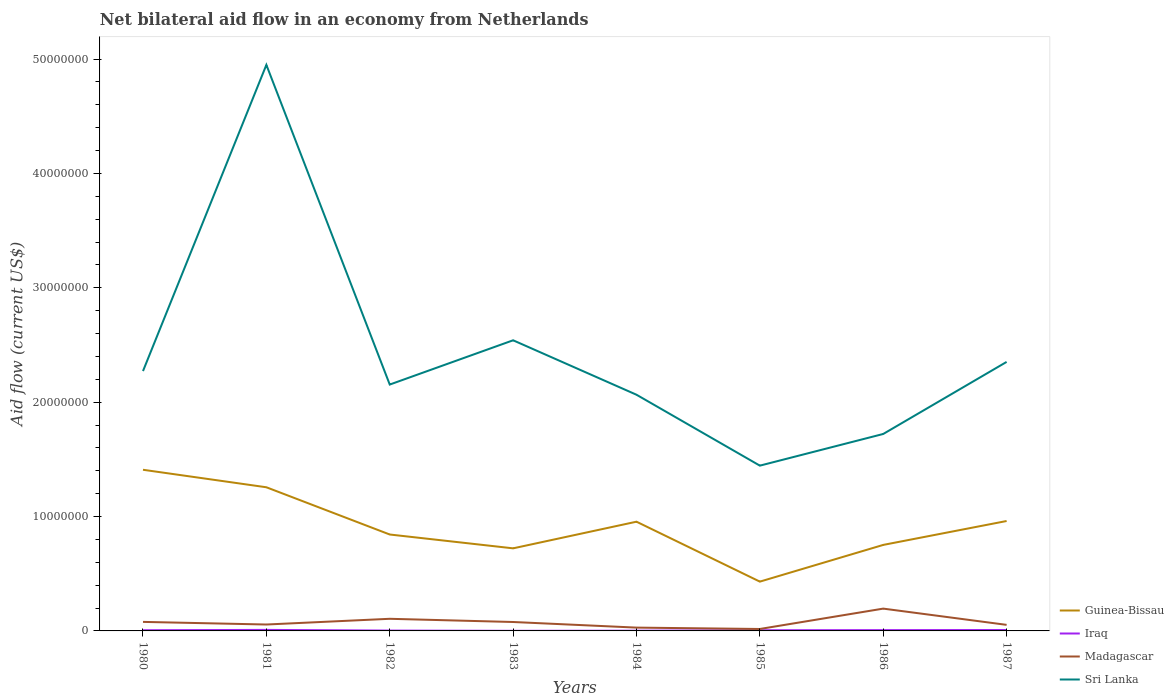What is the total net bilateral aid flow in Guinea-Bissau in the graph?
Offer a terse response. 5.04e+06. What is the difference between the highest and the second highest net bilateral aid flow in Guinea-Bissau?
Provide a short and direct response. 9.78e+06. How many years are there in the graph?
Your response must be concise. 8. Does the graph contain grids?
Provide a short and direct response. No. Where does the legend appear in the graph?
Keep it short and to the point. Bottom right. How are the legend labels stacked?
Provide a short and direct response. Vertical. What is the title of the graph?
Your answer should be compact. Net bilateral aid flow in an economy from Netherlands. What is the label or title of the X-axis?
Offer a terse response. Years. What is the Aid flow (current US$) of Guinea-Bissau in 1980?
Your response must be concise. 1.41e+07. What is the Aid flow (current US$) in Iraq in 1980?
Give a very brief answer. 6.00e+04. What is the Aid flow (current US$) of Madagascar in 1980?
Offer a terse response. 7.90e+05. What is the Aid flow (current US$) of Sri Lanka in 1980?
Ensure brevity in your answer.  2.27e+07. What is the Aid flow (current US$) of Guinea-Bissau in 1981?
Your answer should be compact. 1.26e+07. What is the Aid flow (current US$) in Madagascar in 1981?
Your answer should be very brief. 5.60e+05. What is the Aid flow (current US$) in Sri Lanka in 1981?
Give a very brief answer. 4.95e+07. What is the Aid flow (current US$) in Guinea-Bissau in 1982?
Offer a very short reply. 8.43e+06. What is the Aid flow (current US$) in Iraq in 1982?
Offer a very short reply. 3.00e+04. What is the Aid flow (current US$) of Madagascar in 1982?
Make the answer very short. 1.06e+06. What is the Aid flow (current US$) in Sri Lanka in 1982?
Provide a short and direct response. 2.15e+07. What is the Aid flow (current US$) in Guinea-Bissau in 1983?
Provide a succinct answer. 7.22e+06. What is the Aid flow (current US$) of Iraq in 1983?
Your answer should be very brief. 10000. What is the Aid flow (current US$) in Madagascar in 1983?
Provide a succinct answer. 7.80e+05. What is the Aid flow (current US$) of Sri Lanka in 1983?
Provide a short and direct response. 2.54e+07. What is the Aid flow (current US$) in Guinea-Bissau in 1984?
Offer a very short reply. 9.55e+06. What is the Aid flow (current US$) in Iraq in 1984?
Provide a succinct answer. 2.00e+04. What is the Aid flow (current US$) of Sri Lanka in 1984?
Provide a succinct answer. 2.06e+07. What is the Aid flow (current US$) of Guinea-Bissau in 1985?
Provide a short and direct response. 4.31e+06. What is the Aid flow (current US$) of Iraq in 1985?
Your response must be concise. 6.00e+04. What is the Aid flow (current US$) in Madagascar in 1985?
Give a very brief answer. 1.70e+05. What is the Aid flow (current US$) of Sri Lanka in 1985?
Make the answer very short. 1.44e+07. What is the Aid flow (current US$) of Guinea-Bissau in 1986?
Keep it short and to the point. 7.52e+06. What is the Aid flow (current US$) in Iraq in 1986?
Provide a short and direct response. 7.00e+04. What is the Aid flow (current US$) in Madagascar in 1986?
Keep it short and to the point. 1.95e+06. What is the Aid flow (current US$) of Sri Lanka in 1986?
Your answer should be very brief. 1.72e+07. What is the Aid flow (current US$) in Guinea-Bissau in 1987?
Ensure brevity in your answer.  9.61e+06. What is the Aid flow (current US$) of Iraq in 1987?
Your answer should be very brief. 8.00e+04. What is the Aid flow (current US$) of Madagascar in 1987?
Your answer should be very brief. 5.30e+05. What is the Aid flow (current US$) in Sri Lanka in 1987?
Your answer should be compact. 2.35e+07. Across all years, what is the maximum Aid flow (current US$) in Guinea-Bissau?
Keep it short and to the point. 1.41e+07. Across all years, what is the maximum Aid flow (current US$) in Madagascar?
Your answer should be compact. 1.95e+06. Across all years, what is the maximum Aid flow (current US$) in Sri Lanka?
Provide a succinct answer. 4.95e+07. Across all years, what is the minimum Aid flow (current US$) in Guinea-Bissau?
Your answer should be compact. 4.31e+06. Across all years, what is the minimum Aid flow (current US$) in Sri Lanka?
Provide a succinct answer. 1.44e+07. What is the total Aid flow (current US$) of Guinea-Bissau in the graph?
Your response must be concise. 7.33e+07. What is the total Aid flow (current US$) in Iraq in the graph?
Provide a succinct answer. 4.20e+05. What is the total Aid flow (current US$) in Madagascar in the graph?
Your response must be concise. 6.13e+06. What is the total Aid flow (current US$) of Sri Lanka in the graph?
Make the answer very short. 1.95e+08. What is the difference between the Aid flow (current US$) of Guinea-Bissau in 1980 and that in 1981?
Offer a terse response. 1.53e+06. What is the difference between the Aid flow (current US$) of Iraq in 1980 and that in 1981?
Give a very brief answer. -3.00e+04. What is the difference between the Aid flow (current US$) in Sri Lanka in 1980 and that in 1981?
Make the answer very short. -2.68e+07. What is the difference between the Aid flow (current US$) of Guinea-Bissau in 1980 and that in 1982?
Ensure brevity in your answer.  5.66e+06. What is the difference between the Aid flow (current US$) in Madagascar in 1980 and that in 1982?
Your response must be concise. -2.70e+05. What is the difference between the Aid flow (current US$) of Sri Lanka in 1980 and that in 1982?
Give a very brief answer. 1.18e+06. What is the difference between the Aid flow (current US$) in Guinea-Bissau in 1980 and that in 1983?
Offer a very short reply. 6.87e+06. What is the difference between the Aid flow (current US$) in Iraq in 1980 and that in 1983?
Ensure brevity in your answer.  5.00e+04. What is the difference between the Aid flow (current US$) of Madagascar in 1980 and that in 1983?
Provide a succinct answer. 10000. What is the difference between the Aid flow (current US$) in Sri Lanka in 1980 and that in 1983?
Keep it short and to the point. -2.69e+06. What is the difference between the Aid flow (current US$) in Guinea-Bissau in 1980 and that in 1984?
Ensure brevity in your answer.  4.54e+06. What is the difference between the Aid flow (current US$) in Iraq in 1980 and that in 1984?
Offer a very short reply. 4.00e+04. What is the difference between the Aid flow (current US$) in Madagascar in 1980 and that in 1984?
Ensure brevity in your answer.  5.00e+05. What is the difference between the Aid flow (current US$) in Sri Lanka in 1980 and that in 1984?
Give a very brief answer. 2.07e+06. What is the difference between the Aid flow (current US$) of Guinea-Bissau in 1980 and that in 1985?
Give a very brief answer. 9.78e+06. What is the difference between the Aid flow (current US$) in Iraq in 1980 and that in 1985?
Your answer should be compact. 0. What is the difference between the Aid flow (current US$) of Madagascar in 1980 and that in 1985?
Ensure brevity in your answer.  6.20e+05. What is the difference between the Aid flow (current US$) of Sri Lanka in 1980 and that in 1985?
Ensure brevity in your answer.  8.27e+06. What is the difference between the Aid flow (current US$) in Guinea-Bissau in 1980 and that in 1986?
Ensure brevity in your answer.  6.57e+06. What is the difference between the Aid flow (current US$) in Iraq in 1980 and that in 1986?
Your answer should be compact. -10000. What is the difference between the Aid flow (current US$) of Madagascar in 1980 and that in 1986?
Your answer should be compact. -1.16e+06. What is the difference between the Aid flow (current US$) in Sri Lanka in 1980 and that in 1986?
Your answer should be compact. 5.50e+06. What is the difference between the Aid flow (current US$) of Guinea-Bissau in 1980 and that in 1987?
Give a very brief answer. 4.48e+06. What is the difference between the Aid flow (current US$) in Iraq in 1980 and that in 1987?
Your answer should be very brief. -2.00e+04. What is the difference between the Aid flow (current US$) in Madagascar in 1980 and that in 1987?
Give a very brief answer. 2.60e+05. What is the difference between the Aid flow (current US$) in Sri Lanka in 1980 and that in 1987?
Make the answer very short. -8.00e+05. What is the difference between the Aid flow (current US$) of Guinea-Bissau in 1981 and that in 1982?
Give a very brief answer. 4.13e+06. What is the difference between the Aid flow (current US$) in Madagascar in 1981 and that in 1982?
Keep it short and to the point. -5.00e+05. What is the difference between the Aid flow (current US$) in Sri Lanka in 1981 and that in 1982?
Your answer should be compact. 2.80e+07. What is the difference between the Aid flow (current US$) in Guinea-Bissau in 1981 and that in 1983?
Offer a very short reply. 5.34e+06. What is the difference between the Aid flow (current US$) in Iraq in 1981 and that in 1983?
Provide a succinct answer. 8.00e+04. What is the difference between the Aid flow (current US$) in Sri Lanka in 1981 and that in 1983?
Your answer should be very brief. 2.41e+07. What is the difference between the Aid flow (current US$) of Guinea-Bissau in 1981 and that in 1984?
Your response must be concise. 3.01e+06. What is the difference between the Aid flow (current US$) in Iraq in 1981 and that in 1984?
Your answer should be very brief. 7.00e+04. What is the difference between the Aid flow (current US$) of Sri Lanka in 1981 and that in 1984?
Your answer should be very brief. 2.88e+07. What is the difference between the Aid flow (current US$) in Guinea-Bissau in 1981 and that in 1985?
Your answer should be very brief. 8.25e+06. What is the difference between the Aid flow (current US$) in Iraq in 1981 and that in 1985?
Your answer should be compact. 3.00e+04. What is the difference between the Aid flow (current US$) in Madagascar in 1981 and that in 1985?
Give a very brief answer. 3.90e+05. What is the difference between the Aid flow (current US$) in Sri Lanka in 1981 and that in 1985?
Your answer should be very brief. 3.50e+07. What is the difference between the Aid flow (current US$) of Guinea-Bissau in 1981 and that in 1986?
Provide a succinct answer. 5.04e+06. What is the difference between the Aid flow (current US$) in Iraq in 1981 and that in 1986?
Your answer should be compact. 2.00e+04. What is the difference between the Aid flow (current US$) in Madagascar in 1981 and that in 1986?
Ensure brevity in your answer.  -1.39e+06. What is the difference between the Aid flow (current US$) in Sri Lanka in 1981 and that in 1986?
Make the answer very short. 3.23e+07. What is the difference between the Aid flow (current US$) in Guinea-Bissau in 1981 and that in 1987?
Offer a very short reply. 2.95e+06. What is the difference between the Aid flow (current US$) in Iraq in 1981 and that in 1987?
Give a very brief answer. 10000. What is the difference between the Aid flow (current US$) in Madagascar in 1981 and that in 1987?
Offer a very short reply. 3.00e+04. What is the difference between the Aid flow (current US$) in Sri Lanka in 1981 and that in 1987?
Your answer should be compact. 2.60e+07. What is the difference between the Aid flow (current US$) in Guinea-Bissau in 1982 and that in 1983?
Your answer should be compact. 1.21e+06. What is the difference between the Aid flow (current US$) in Madagascar in 1982 and that in 1983?
Keep it short and to the point. 2.80e+05. What is the difference between the Aid flow (current US$) of Sri Lanka in 1982 and that in 1983?
Offer a terse response. -3.87e+06. What is the difference between the Aid flow (current US$) in Guinea-Bissau in 1982 and that in 1984?
Provide a short and direct response. -1.12e+06. What is the difference between the Aid flow (current US$) in Iraq in 1982 and that in 1984?
Make the answer very short. 10000. What is the difference between the Aid flow (current US$) of Madagascar in 1982 and that in 1984?
Give a very brief answer. 7.70e+05. What is the difference between the Aid flow (current US$) of Sri Lanka in 1982 and that in 1984?
Your answer should be very brief. 8.90e+05. What is the difference between the Aid flow (current US$) of Guinea-Bissau in 1982 and that in 1985?
Offer a terse response. 4.12e+06. What is the difference between the Aid flow (current US$) in Madagascar in 1982 and that in 1985?
Provide a short and direct response. 8.90e+05. What is the difference between the Aid flow (current US$) of Sri Lanka in 1982 and that in 1985?
Offer a very short reply. 7.09e+06. What is the difference between the Aid flow (current US$) of Guinea-Bissau in 1982 and that in 1986?
Make the answer very short. 9.10e+05. What is the difference between the Aid flow (current US$) of Madagascar in 1982 and that in 1986?
Make the answer very short. -8.90e+05. What is the difference between the Aid flow (current US$) of Sri Lanka in 1982 and that in 1986?
Keep it short and to the point. 4.32e+06. What is the difference between the Aid flow (current US$) in Guinea-Bissau in 1982 and that in 1987?
Offer a terse response. -1.18e+06. What is the difference between the Aid flow (current US$) of Madagascar in 1982 and that in 1987?
Give a very brief answer. 5.30e+05. What is the difference between the Aid flow (current US$) of Sri Lanka in 1982 and that in 1987?
Your answer should be very brief. -1.98e+06. What is the difference between the Aid flow (current US$) of Guinea-Bissau in 1983 and that in 1984?
Make the answer very short. -2.33e+06. What is the difference between the Aid flow (current US$) in Iraq in 1983 and that in 1984?
Make the answer very short. -10000. What is the difference between the Aid flow (current US$) of Sri Lanka in 1983 and that in 1984?
Your answer should be very brief. 4.76e+06. What is the difference between the Aid flow (current US$) of Guinea-Bissau in 1983 and that in 1985?
Your answer should be compact. 2.91e+06. What is the difference between the Aid flow (current US$) in Madagascar in 1983 and that in 1985?
Your response must be concise. 6.10e+05. What is the difference between the Aid flow (current US$) of Sri Lanka in 1983 and that in 1985?
Your answer should be compact. 1.10e+07. What is the difference between the Aid flow (current US$) of Madagascar in 1983 and that in 1986?
Your response must be concise. -1.17e+06. What is the difference between the Aid flow (current US$) of Sri Lanka in 1983 and that in 1986?
Make the answer very short. 8.19e+06. What is the difference between the Aid flow (current US$) in Guinea-Bissau in 1983 and that in 1987?
Give a very brief answer. -2.39e+06. What is the difference between the Aid flow (current US$) in Madagascar in 1983 and that in 1987?
Give a very brief answer. 2.50e+05. What is the difference between the Aid flow (current US$) of Sri Lanka in 1983 and that in 1987?
Your answer should be very brief. 1.89e+06. What is the difference between the Aid flow (current US$) of Guinea-Bissau in 1984 and that in 1985?
Provide a succinct answer. 5.24e+06. What is the difference between the Aid flow (current US$) of Iraq in 1984 and that in 1985?
Your answer should be very brief. -4.00e+04. What is the difference between the Aid flow (current US$) of Sri Lanka in 1984 and that in 1985?
Provide a short and direct response. 6.20e+06. What is the difference between the Aid flow (current US$) of Guinea-Bissau in 1984 and that in 1986?
Your answer should be very brief. 2.03e+06. What is the difference between the Aid flow (current US$) in Madagascar in 1984 and that in 1986?
Offer a terse response. -1.66e+06. What is the difference between the Aid flow (current US$) of Sri Lanka in 1984 and that in 1986?
Provide a succinct answer. 3.43e+06. What is the difference between the Aid flow (current US$) of Iraq in 1984 and that in 1987?
Offer a terse response. -6.00e+04. What is the difference between the Aid flow (current US$) of Madagascar in 1984 and that in 1987?
Provide a succinct answer. -2.40e+05. What is the difference between the Aid flow (current US$) in Sri Lanka in 1984 and that in 1987?
Your answer should be compact. -2.87e+06. What is the difference between the Aid flow (current US$) in Guinea-Bissau in 1985 and that in 1986?
Provide a short and direct response. -3.21e+06. What is the difference between the Aid flow (current US$) in Madagascar in 1985 and that in 1986?
Offer a terse response. -1.78e+06. What is the difference between the Aid flow (current US$) in Sri Lanka in 1985 and that in 1986?
Make the answer very short. -2.77e+06. What is the difference between the Aid flow (current US$) of Guinea-Bissau in 1985 and that in 1987?
Give a very brief answer. -5.30e+06. What is the difference between the Aid flow (current US$) in Madagascar in 1985 and that in 1987?
Keep it short and to the point. -3.60e+05. What is the difference between the Aid flow (current US$) of Sri Lanka in 1985 and that in 1987?
Provide a short and direct response. -9.07e+06. What is the difference between the Aid flow (current US$) of Guinea-Bissau in 1986 and that in 1987?
Your answer should be very brief. -2.09e+06. What is the difference between the Aid flow (current US$) in Iraq in 1986 and that in 1987?
Make the answer very short. -10000. What is the difference between the Aid flow (current US$) of Madagascar in 1986 and that in 1987?
Your response must be concise. 1.42e+06. What is the difference between the Aid flow (current US$) of Sri Lanka in 1986 and that in 1987?
Your answer should be compact. -6.30e+06. What is the difference between the Aid flow (current US$) in Guinea-Bissau in 1980 and the Aid flow (current US$) in Iraq in 1981?
Keep it short and to the point. 1.40e+07. What is the difference between the Aid flow (current US$) in Guinea-Bissau in 1980 and the Aid flow (current US$) in Madagascar in 1981?
Your answer should be compact. 1.35e+07. What is the difference between the Aid flow (current US$) in Guinea-Bissau in 1980 and the Aid flow (current US$) in Sri Lanka in 1981?
Provide a succinct answer. -3.54e+07. What is the difference between the Aid flow (current US$) of Iraq in 1980 and the Aid flow (current US$) of Madagascar in 1981?
Make the answer very short. -5.00e+05. What is the difference between the Aid flow (current US$) of Iraq in 1980 and the Aid flow (current US$) of Sri Lanka in 1981?
Ensure brevity in your answer.  -4.94e+07. What is the difference between the Aid flow (current US$) of Madagascar in 1980 and the Aid flow (current US$) of Sri Lanka in 1981?
Your answer should be compact. -4.87e+07. What is the difference between the Aid flow (current US$) of Guinea-Bissau in 1980 and the Aid flow (current US$) of Iraq in 1982?
Your response must be concise. 1.41e+07. What is the difference between the Aid flow (current US$) of Guinea-Bissau in 1980 and the Aid flow (current US$) of Madagascar in 1982?
Make the answer very short. 1.30e+07. What is the difference between the Aid flow (current US$) of Guinea-Bissau in 1980 and the Aid flow (current US$) of Sri Lanka in 1982?
Offer a very short reply. -7.45e+06. What is the difference between the Aid flow (current US$) of Iraq in 1980 and the Aid flow (current US$) of Madagascar in 1982?
Ensure brevity in your answer.  -1.00e+06. What is the difference between the Aid flow (current US$) of Iraq in 1980 and the Aid flow (current US$) of Sri Lanka in 1982?
Make the answer very short. -2.15e+07. What is the difference between the Aid flow (current US$) of Madagascar in 1980 and the Aid flow (current US$) of Sri Lanka in 1982?
Your answer should be very brief. -2.08e+07. What is the difference between the Aid flow (current US$) in Guinea-Bissau in 1980 and the Aid flow (current US$) in Iraq in 1983?
Offer a very short reply. 1.41e+07. What is the difference between the Aid flow (current US$) in Guinea-Bissau in 1980 and the Aid flow (current US$) in Madagascar in 1983?
Ensure brevity in your answer.  1.33e+07. What is the difference between the Aid flow (current US$) of Guinea-Bissau in 1980 and the Aid flow (current US$) of Sri Lanka in 1983?
Make the answer very short. -1.13e+07. What is the difference between the Aid flow (current US$) of Iraq in 1980 and the Aid flow (current US$) of Madagascar in 1983?
Your answer should be compact. -7.20e+05. What is the difference between the Aid flow (current US$) in Iraq in 1980 and the Aid flow (current US$) in Sri Lanka in 1983?
Offer a very short reply. -2.54e+07. What is the difference between the Aid flow (current US$) in Madagascar in 1980 and the Aid flow (current US$) in Sri Lanka in 1983?
Provide a short and direct response. -2.46e+07. What is the difference between the Aid flow (current US$) of Guinea-Bissau in 1980 and the Aid flow (current US$) of Iraq in 1984?
Provide a succinct answer. 1.41e+07. What is the difference between the Aid flow (current US$) of Guinea-Bissau in 1980 and the Aid flow (current US$) of Madagascar in 1984?
Keep it short and to the point. 1.38e+07. What is the difference between the Aid flow (current US$) in Guinea-Bissau in 1980 and the Aid flow (current US$) in Sri Lanka in 1984?
Your response must be concise. -6.56e+06. What is the difference between the Aid flow (current US$) of Iraq in 1980 and the Aid flow (current US$) of Sri Lanka in 1984?
Offer a terse response. -2.06e+07. What is the difference between the Aid flow (current US$) in Madagascar in 1980 and the Aid flow (current US$) in Sri Lanka in 1984?
Keep it short and to the point. -1.99e+07. What is the difference between the Aid flow (current US$) of Guinea-Bissau in 1980 and the Aid flow (current US$) of Iraq in 1985?
Provide a short and direct response. 1.40e+07. What is the difference between the Aid flow (current US$) of Guinea-Bissau in 1980 and the Aid flow (current US$) of Madagascar in 1985?
Offer a terse response. 1.39e+07. What is the difference between the Aid flow (current US$) in Guinea-Bissau in 1980 and the Aid flow (current US$) in Sri Lanka in 1985?
Offer a very short reply. -3.60e+05. What is the difference between the Aid flow (current US$) of Iraq in 1980 and the Aid flow (current US$) of Madagascar in 1985?
Offer a very short reply. -1.10e+05. What is the difference between the Aid flow (current US$) in Iraq in 1980 and the Aid flow (current US$) in Sri Lanka in 1985?
Offer a very short reply. -1.44e+07. What is the difference between the Aid flow (current US$) of Madagascar in 1980 and the Aid flow (current US$) of Sri Lanka in 1985?
Keep it short and to the point. -1.37e+07. What is the difference between the Aid flow (current US$) in Guinea-Bissau in 1980 and the Aid flow (current US$) in Iraq in 1986?
Provide a short and direct response. 1.40e+07. What is the difference between the Aid flow (current US$) in Guinea-Bissau in 1980 and the Aid flow (current US$) in Madagascar in 1986?
Your answer should be very brief. 1.21e+07. What is the difference between the Aid flow (current US$) of Guinea-Bissau in 1980 and the Aid flow (current US$) of Sri Lanka in 1986?
Provide a succinct answer. -3.13e+06. What is the difference between the Aid flow (current US$) of Iraq in 1980 and the Aid flow (current US$) of Madagascar in 1986?
Offer a very short reply. -1.89e+06. What is the difference between the Aid flow (current US$) in Iraq in 1980 and the Aid flow (current US$) in Sri Lanka in 1986?
Keep it short and to the point. -1.72e+07. What is the difference between the Aid flow (current US$) in Madagascar in 1980 and the Aid flow (current US$) in Sri Lanka in 1986?
Your response must be concise. -1.64e+07. What is the difference between the Aid flow (current US$) of Guinea-Bissau in 1980 and the Aid flow (current US$) of Iraq in 1987?
Your answer should be compact. 1.40e+07. What is the difference between the Aid flow (current US$) of Guinea-Bissau in 1980 and the Aid flow (current US$) of Madagascar in 1987?
Give a very brief answer. 1.36e+07. What is the difference between the Aid flow (current US$) in Guinea-Bissau in 1980 and the Aid flow (current US$) in Sri Lanka in 1987?
Your response must be concise. -9.43e+06. What is the difference between the Aid flow (current US$) of Iraq in 1980 and the Aid flow (current US$) of Madagascar in 1987?
Ensure brevity in your answer.  -4.70e+05. What is the difference between the Aid flow (current US$) in Iraq in 1980 and the Aid flow (current US$) in Sri Lanka in 1987?
Provide a short and direct response. -2.35e+07. What is the difference between the Aid flow (current US$) of Madagascar in 1980 and the Aid flow (current US$) of Sri Lanka in 1987?
Your answer should be very brief. -2.27e+07. What is the difference between the Aid flow (current US$) in Guinea-Bissau in 1981 and the Aid flow (current US$) in Iraq in 1982?
Keep it short and to the point. 1.25e+07. What is the difference between the Aid flow (current US$) in Guinea-Bissau in 1981 and the Aid flow (current US$) in Madagascar in 1982?
Your answer should be compact. 1.15e+07. What is the difference between the Aid flow (current US$) of Guinea-Bissau in 1981 and the Aid flow (current US$) of Sri Lanka in 1982?
Provide a succinct answer. -8.98e+06. What is the difference between the Aid flow (current US$) in Iraq in 1981 and the Aid flow (current US$) in Madagascar in 1982?
Give a very brief answer. -9.70e+05. What is the difference between the Aid flow (current US$) in Iraq in 1981 and the Aid flow (current US$) in Sri Lanka in 1982?
Give a very brief answer. -2.14e+07. What is the difference between the Aid flow (current US$) of Madagascar in 1981 and the Aid flow (current US$) of Sri Lanka in 1982?
Offer a terse response. -2.10e+07. What is the difference between the Aid flow (current US$) in Guinea-Bissau in 1981 and the Aid flow (current US$) in Iraq in 1983?
Make the answer very short. 1.26e+07. What is the difference between the Aid flow (current US$) of Guinea-Bissau in 1981 and the Aid flow (current US$) of Madagascar in 1983?
Your answer should be compact. 1.18e+07. What is the difference between the Aid flow (current US$) of Guinea-Bissau in 1981 and the Aid flow (current US$) of Sri Lanka in 1983?
Keep it short and to the point. -1.28e+07. What is the difference between the Aid flow (current US$) of Iraq in 1981 and the Aid flow (current US$) of Madagascar in 1983?
Provide a short and direct response. -6.90e+05. What is the difference between the Aid flow (current US$) of Iraq in 1981 and the Aid flow (current US$) of Sri Lanka in 1983?
Make the answer very short. -2.53e+07. What is the difference between the Aid flow (current US$) in Madagascar in 1981 and the Aid flow (current US$) in Sri Lanka in 1983?
Your response must be concise. -2.48e+07. What is the difference between the Aid flow (current US$) of Guinea-Bissau in 1981 and the Aid flow (current US$) of Iraq in 1984?
Give a very brief answer. 1.25e+07. What is the difference between the Aid flow (current US$) of Guinea-Bissau in 1981 and the Aid flow (current US$) of Madagascar in 1984?
Your response must be concise. 1.23e+07. What is the difference between the Aid flow (current US$) in Guinea-Bissau in 1981 and the Aid flow (current US$) in Sri Lanka in 1984?
Your response must be concise. -8.09e+06. What is the difference between the Aid flow (current US$) of Iraq in 1981 and the Aid flow (current US$) of Sri Lanka in 1984?
Provide a short and direct response. -2.06e+07. What is the difference between the Aid flow (current US$) in Madagascar in 1981 and the Aid flow (current US$) in Sri Lanka in 1984?
Make the answer very short. -2.01e+07. What is the difference between the Aid flow (current US$) in Guinea-Bissau in 1981 and the Aid flow (current US$) in Iraq in 1985?
Make the answer very short. 1.25e+07. What is the difference between the Aid flow (current US$) of Guinea-Bissau in 1981 and the Aid flow (current US$) of Madagascar in 1985?
Ensure brevity in your answer.  1.24e+07. What is the difference between the Aid flow (current US$) of Guinea-Bissau in 1981 and the Aid flow (current US$) of Sri Lanka in 1985?
Keep it short and to the point. -1.89e+06. What is the difference between the Aid flow (current US$) in Iraq in 1981 and the Aid flow (current US$) in Sri Lanka in 1985?
Offer a terse response. -1.44e+07. What is the difference between the Aid flow (current US$) in Madagascar in 1981 and the Aid flow (current US$) in Sri Lanka in 1985?
Your response must be concise. -1.39e+07. What is the difference between the Aid flow (current US$) in Guinea-Bissau in 1981 and the Aid flow (current US$) in Iraq in 1986?
Make the answer very short. 1.25e+07. What is the difference between the Aid flow (current US$) in Guinea-Bissau in 1981 and the Aid flow (current US$) in Madagascar in 1986?
Make the answer very short. 1.06e+07. What is the difference between the Aid flow (current US$) in Guinea-Bissau in 1981 and the Aid flow (current US$) in Sri Lanka in 1986?
Offer a very short reply. -4.66e+06. What is the difference between the Aid flow (current US$) in Iraq in 1981 and the Aid flow (current US$) in Madagascar in 1986?
Offer a terse response. -1.86e+06. What is the difference between the Aid flow (current US$) of Iraq in 1981 and the Aid flow (current US$) of Sri Lanka in 1986?
Make the answer very short. -1.71e+07. What is the difference between the Aid flow (current US$) in Madagascar in 1981 and the Aid flow (current US$) in Sri Lanka in 1986?
Ensure brevity in your answer.  -1.67e+07. What is the difference between the Aid flow (current US$) in Guinea-Bissau in 1981 and the Aid flow (current US$) in Iraq in 1987?
Give a very brief answer. 1.25e+07. What is the difference between the Aid flow (current US$) in Guinea-Bissau in 1981 and the Aid flow (current US$) in Madagascar in 1987?
Offer a terse response. 1.20e+07. What is the difference between the Aid flow (current US$) in Guinea-Bissau in 1981 and the Aid flow (current US$) in Sri Lanka in 1987?
Your response must be concise. -1.10e+07. What is the difference between the Aid flow (current US$) in Iraq in 1981 and the Aid flow (current US$) in Madagascar in 1987?
Offer a very short reply. -4.40e+05. What is the difference between the Aid flow (current US$) in Iraq in 1981 and the Aid flow (current US$) in Sri Lanka in 1987?
Your response must be concise. -2.34e+07. What is the difference between the Aid flow (current US$) of Madagascar in 1981 and the Aid flow (current US$) of Sri Lanka in 1987?
Provide a succinct answer. -2.30e+07. What is the difference between the Aid flow (current US$) in Guinea-Bissau in 1982 and the Aid flow (current US$) in Iraq in 1983?
Your answer should be compact. 8.42e+06. What is the difference between the Aid flow (current US$) of Guinea-Bissau in 1982 and the Aid flow (current US$) of Madagascar in 1983?
Make the answer very short. 7.65e+06. What is the difference between the Aid flow (current US$) of Guinea-Bissau in 1982 and the Aid flow (current US$) of Sri Lanka in 1983?
Your response must be concise. -1.70e+07. What is the difference between the Aid flow (current US$) in Iraq in 1982 and the Aid flow (current US$) in Madagascar in 1983?
Make the answer very short. -7.50e+05. What is the difference between the Aid flow (current US$) of Iraq in 1982 and the Aid flow (current US$) of Sri Lanka in 1983?
Offer a very short reply. -2.54e+07. What is the difference between the Aid flow (current US$) of Madagascar in 1982 and the Aid flow (current US$) of Sri Lanka in 1983?
Your response must be concise. -2.44e+07. What is the difference between the Aid flow (current US$) of Guinea-Bissau in 1982 and the Aid flow (current US$) of Iraq in 1984?
Make the answer very short. 8.41e+06. What is the difference between the Aid flow (current US$) in Guinea-Bissau in 1982 and the Aid flow (current US$) in Madagascar in 1984?
Make the answer very short. 8.14e+06. What is the difference between the Aid flow (current US$) in Guinea-Bissau in 1982 and the Aid flow (current US$) in Sri Lanka in 1984?
Give a very brief answer. -1.22e+07. What is the difference between the Aid flow (current US$) in Iraq in 1982 and the Aid flow (current US$) in Sri Lanka in 1984?
Your response must be concise. -2.06e+07. What is the difference between the Aid flow (current US$) of Madagascar in 1982 and the Aid flow (current US$) of Sri Lanka in 1984?
Your answer should be very brief. -1.96e+07. What is the difference between the Aid flow (current US$) of Guinea-Bissau in 1982 and the Aid flow (current US$) of Iraq in 1985?
Ensure brevity in your answer.  8.37e+06. What is the difference between the Aid flow (current US$) in Guinea-Bissau in 1982 and the Aid flow (current US$) in Madagascar in 1985?
Make the answer very short. 8.26e+06. What is the difference between the Aid flow (current US$) of Guinea-Bissau in 1982 and the Aid flow (current US$) of Sri Lanka in 1985?
Ensure brevity in your answer.  -6.02e+06. What is the difference between the Aid flow (current US$) of Iraq in 1982 and the Aid flow (current US$) of Sri Lanka in 1985?
Offer a terse response. -1.44e+07. What is the difference between the Aid flow (current US$) of Madagascar in 1982 and the Aid flow (current US$) of Sri Lanka in 1985?
Keep it short and to the point. -1.34e+07. What is the difference between the Aid flow (current US$) in Guinea-Bissau in 1982 and the Aid flow (current US$) in Iraq in 1986?
Your answer should be very brief. 8.36e+06. What is the difference between the Aid flow (current US$) of Guinea-Bissau in 1982 and the Aid flow (current US$) of Madagascar in 1986?
Your response must be concise. 6.48e+06. What is the difference between the Aid flow (current US$) in Guinea-Bissau in 1982 and the Aid flow (current US$) in Sri Lanka in 1986?
Ensure brevity in your answer.  -8.79e+06. What is the difference between the Aid flow (current US$) of Iraq in 1982 and the Aid flow (current US$) of Madagascar in 1986?
Your response must be concise. -1.92e+06. What is the difference between the Aid flow (current US$) of Iraq in 1982 and the Aid flow (current US$) of Sri Lanka in 1986?
Make the answer very short. -1.72e+07. What is the difference between the Aid flow (current US$) in Madagascar in 1982 and the Aid flow (current US$) in Sri Lanka in 1986?
Your response must be concise. -1.62e+07. What is the difference between the Aid flow (current US$) in Guinea-Bissau in 1982 and the Aid flow (current US$) in Iraq in 1987?
Offer a very short reply. 8.35e+06. What is the difference between the Aid flow (current US$) in Guinea-Bissau in 1982 and the Aid flow (current US$) in Madagascar in 1987?
Make the answer very short. 7.90e+06. What is the difference between the Aid flow (current US$) of Guinea-Bissau in 1982 and the Aid flow (current US$) of Sri Lanka in 1987?
Your answer should be compact. -1.51e+07. What is the difference between the Aid flow (current US$) in Iraq in 1982 and the Aid flow (current US$) in Madagascar in 1987?
Offer a very short reply. -5.00e+05. What is the difference between the Aid flow (current US$) in Iraq in 1982 and the Aid flow (current US$) in Sri Lanka in 1987?
Offer a very short reply. -2.35e+07. What is the difference between the Aid flow (current US$) in Madagascar in 1982 and the Aid flow (current US$) in Sri Lanka in 1987?
Ensure brevity in your answer.  -2.25e+07. What is the difference between the Aid flow (current US$) in Guinea-Bissau in 1983 and the Aid flow (current US$) in Iraq in 1984?
Your answer should be very brief. 7.20e+06. What is the difference between the Aid flow (current US$) of Guinea-Bissau in 1983 and the Aid flow (current US$) of Madagascar in 1984?
Give a very brief answer. 6.93e+06. What is the difference between the Aid flow (current US$) in Guinea-Bissau in 1983 and the Aid flow (current US$) in Sri Lanka in 1984?
Give a very brief answer. -1.34e+07. What is the difference between the Aid flow (current US$) in Iraq in 1983 and the Aid flow (current US$) in Madagascar in 1984?
Provide a short and direct response. -2.80e+05. What is the difference between the Aid flow (current US$) of Iraq in 1983 and the Aid flow (current US$) of Sri Lanka in 1984?
Your answer should be compact. -2.06e+07. What is the difference between the Aid flow (current US$) in Madagascar in 1983 and the Aid flow (current US$) in Sri Lanka in 1984?
Your answer should be very brief. -1.99e+07. What is the difference between the Aid flow (current US$) in Guinea-Bissau in 1983 and the Aid flow (current US$) in Iraq in 1985?
Your response must be concise. 7.16e+06. What is the difference between the Aid flow (current US$) of Guinea-Bissau in 1983 and the Aid flow (current US$) of Madagascar in 1985?
Your response must be concise. 7.05e+06. What is the difference between the Aid flow (current US$) in Guinea-Bissau in 1983 and the Aid flow (current US$) in Sri Lanka in 1985?
Make the answer very short. -7.23e+06. What is the difference between the Aid flow (current US$) of Iraq in 1983 and the Aid flow (current US$) of Madagascar in 1985?
Ensure brevity in your answer.  -1.60e+05. What is the difference between the Aid flow (current US$) in Iraq in 1983 and the Aid flow (current US$) in Sri Lanka in 1985?
Your answer should be very brief. -1.44e+07. What is the difference between the Aid flow (current US$) in Madagascar in 1983 and the Aid flow (current US$) in Sri Lanka in 1985?
Ensure brevity in your answer.  -1.37e+07. What is the difference between the Aid flow (current US$) in Guinea-Bissau in 1983 and the Aid flow (current US$) in Iraq in 1986?
Provide a short and direct response. 7.15e+06. What is the difference between the Aid flow (current US$) of Guinea-Bissau in 1983 and the Aid flow (current US$) of Madagascar in 1986?
Your answer should be compact. 5.27e+06. What is the difference between the Aid flow (current US$) of Guinea-Bissau in 1983 and the Aid flow (current US$) of Sri Lanka in 1986?
Your answer should be compact. -1.00e+07. What is the difference between the Aid flow (current US$) in Iraq in 1983 and the Aid flow (current US$) in Madagascar in 1986?
Give a very brief answer. -1.94e+06. What is the difference between the Aid flow (current US$) in Iraq in 1983 and the Aid flow (current US$) in Sri Lanka in 1986?
Offer a terse response. -1.72e+07. What is the difference between the Aid flow (current US$) in Madagascar in 1983 and the Aid flow (current US$) in Sri Lanka in 1986?
Offer a terse response. -1.64e+07. What is the difference between the Aid flow (current US$) in Guinea-Bissau in 1983 and the Aid flow (current US$) in Iraq in 1987?
Offer a terse response. 7.14e+06. What is the difference between the Aid flow (current US$) of Guinea-Bissau in 1983 and the Aid flow (current US$) of Madagascar in 1987?
Your answer should be very brief. 6.69e+06. What is the difference between the Aid flow (current US$) of Guinea-Bissau in 1983 and the Aid flow (current US$) of Sri Lanka in 1987?
Offer a terse response. -1.63e+07. What is the difference between the Aid flow (current US$) of Iraq in 1983 and the Aid flow (current US$) of Madagascar in 1987?
Provide a short and direct response. -5.20e+05. What is the difference between the Aid flow (current US$) in Iraq in 1983 and the Aid flow (current US$) in Sri Lanka in 1987?
Offer a very short reply. -2.35e+07. What is the difference between the Aid flow (current US$) in Madagascar in 1983 and the Aid flow (current US$) in Sri Lanka in 1987?
Keep it short and to the point. -2.27e+07. What is the difference between the Aid flow (current US$) in Guinea-Bissau in 1984 and the Aid flow (current US$) in Iraq in 1985?
Provide a succinct answer. 9.49e+06. What is the difference between the Aid flow (current US$) of Guinea-Bissau in 1984 and the Aid flow (current US$) of Madagascar in 1985?
Offer a terse response. 9.38e+06. What is the difference between the Aid flow (current US$) in Guinea-Bissau in 1984 and the Aid flow (current US$) in Sri Lanka in 1985?
Offer a very short reply. -4.90e+06. What is the difference between the Aid flow (current US$) of Iraq in 1984 and the Aid flow (current US$) of Sri Lanka in 1985?
Ensure brevity in your answer.  -1.44e+07. What is the difference between the Aid flow (current US$) of Madagascar in 1984 and the Aid flow (current US$) of Sri Lanka in 1985?
Your answer should be compact. -1.42e+07. What is the difference between the Aid flow (current US$) in Guinea-Bissau in 1984 and the Aid flow (current US$) in Iraq in 1986?
Your response must be concise. 9.48e+06. What is the difference between the Aid flow (current US$) in Guinea-Bissau in 1984 and the Aid flow (current US$) in Madagascar in 1986?
Your answer should be compact. 7.60e+06. What is the difference between the Aid flow (current US$) of Guinea-Bissau in 1984 and the Aid flow (current US$) of Sri Lanka in 1986?
Provide a succinct answer. -7.67e+06. What is the difference between the Aid flow (current US$) in Iraq in 1984 and the Aid flow (current US$) in Madagascar in 1986?
Give a very brief answer. -1.93e+06. What is the difference between the Aid flow (current US$) of Iraq in 1984 and the Aid flow (current US$) of Sri Lanka in 1986?
Make the answer very short. -1.72e+07. What is the difference between the Aid flow (current US$) of Madagascar in 1984 and the Aid flow (current US$) of Sri Lanka in 1986?
Provide a succinct answer. -1.69e+07. What is the difference between the Aid flow (current US$) of Guinea-Bissau in 1984 and the Aid flow (current US$) of Iraq in 1987?
Make the answer very short. 9.47e+06. What is the difference between the Aid flow (current US$) of Guinea-Bissau in 1984 and the Aid flow (current US$) of Madagascar in 1987?
Provide a succinct answer. 9.02e+06. What is the difference between the Aid flow (current US$) in Guinea-Bissau in 1984 and the Aid flow (current US$) in Sri Lanka in 1987?
Offer a very short reply. -1.40e+07. What is the difference between the Aid flow (current US$) in Iraq in 1984 and the Aid flow (current US$) in Madagascar in 1987?
Your response must be concise. -5.10e+05. What is the difference between the Aid flow (current US$) of Iraq in 1984 and the Aid flow (current US$) of Sri Lanka in 1987?
Offer a very short reply. -2.35e+07. What is the difference between the Aid flow (current US$) of Madagascar in 1984 and the Aid flow (current US$) of Sri Lanka in 1987?
Your response must be concise. -2.32e+07. What is the difference between the Aid flow (current US$) in Guinea-Bissau in 1985 and the Aid flow (current US$) in Iraq in 1986?
Provide a succinct answer. 4.24e+06. What is the difference between the Aid flow (current US$) of Guinea-Bissau in 1985 and the Aid flow (current US$) of Madagascar in 1986?
Your response must be concise. 2.36e+06. What is the difference between the Aid flow (current US$) in Guinea-Bissau in 1985 and the Aid flow (current US$) in Sri Lanka in 1986?
Make the answer very short. -1.29e+07. What is the difference between the Aid flow (current US$) in Iraq in 1985 and the Aid flow (current US$) in Madagascar in 1986?
Provide a succinct answer. -1.89e+06. What is the difference between the Aid flow (current US$) of Iraq in 1985 and the Aid flow (current US$) of Sri Lanka in 1986?
Provide a short and direct response. -1.72e+07. What is the difference between the Aid flow (current US$) of Madagascar in 1985 and the Aid flow (current US$) of Sri Lanka in 1986?
Provide a succinct answer. -1.70e+07. What is the difference between the Aid flow (current US$) of Guinea-Bissau in 1985 and the Aid flow (current US$) of Iraq in 1987?
Provide a succinct answer. 4.23e+06. What is the difference between the Aid flow (current US$) of Guinea-Bissau in 1985 and the Aid flow (current US$) of Madagascar in 1987?
Your response must be concise. 3.78e+06. What is the difference between the Aid flow (current US$) in Guinea-Bissau in 1985 and the Aid flow (current US$) in Sri Lanka in 1987?
Provide a succinct answer. -1.92e+07. What is the difference between the Aid flow (current US$) of Iraq in 1985 and the Aid flow (current US$) of Madagascar in 1987?
Keep it short and to the point. -4.70e+05. What is the difference between the Aid flow (current US$) of Iraq in 1985 and the Aid flow (current US$) of Sri Lanka in 1987?
Your answer should be compact. -2.35e+07. What is the difference between the Aid flow (current US$) of Madagascar in 1985 and the Aid flow (current US$) of Sri Lanka in 1987?
Make the answer very short. -2.34e+07. What is the difference between the Aid flow (current US$) in Guinea-Bissau in 1986 and the Aid flow (current US$) in Iraq in 1987?
Ensure brevity in your answer.  7.44e+06. What is the difference between the Aid flow (current US$) of Guinea-Bissau in 1986 and the Aid flow (current US$) of Madagascar in 1987?
Keep it short and to the point. 6.99e+06. What is the difference between the Aid flow (current US$) in Guinea-Bissau in 1986 and the Aid flow (current US$) in Sri Lanka in 1987?
Provide a short and direct response. -1.60e+07. What is the difference between the Aid flow (current US$) in Iraq in 1986 and the Aid flow (current US$) in Madagascar in 1987?
Keep it short and to the point. -4.60e+05. What is the difference between the Aid flow (current US$) of Iraq in 1986 and the Aid flow (current US$) of Sri Lanka in 1987?
Provide a short and direct response. -2.34e+07. What is the difference between the Aid flow (current US$) in Madagascar in 1986 and the Aid flow (current US$) in Sri Lanka in 1987?
Your answer should be compact. -2.16e+07. What is the average Aid flow (current US$) of Guinea-Bissau per year?
Give a very brief answer. 9.16e+06. What is the average Aid flow (current US$) in Iraq per year?
Ensure brevity in your answer.  5.25e+04. What is the average Aid flow (current US$) of Madagascar per year?
Offer a terse response. 7.66e+05. What is the average Aid flow (current US$) of Sri Lanka per year?
Keep it short and to the point. 2.44e+07. In the year 1980, what is the difference between the Aid flow (current US$) of Guinea-Bissau and Aid flow (current US$) of Iraq?
Give a very brief answer. 1.40e+07. In the year 1980, what is the difference between the Aid flow (current US$) of Guinea-Bissau and Aid flow (current US$) of Madagascar?
Give a very brief answer. 1.33e+07. In the year 1980, what is the difference between the Aid flow (current US$) of Guinea-Bissau and Aid flow (current US$) of Sri Lanka?
Make the answer very short. -8.63e+06. In the year 1980, what is the difference between the Aid flow (current US$) of Iraq and Aid flow (current US$) of Madagascar?
Give a very brief answer. -7.30e+05. In the year 1980, what is the difference between the Aid flow (current US$) in Iraq and Aid flow (current US$) in Sri Lanka?
Give a very brief answer. -2.27e+07. In the year 1980, what is the difference between the Aid flow (current US$) of Madagascar and Aid flow (current US$) of Sri Lanka?
Provide a succinct answer. -2.19e+07. In the year 1981, what is the difference between the Aid flow (current US$) in Guinea-Bissau and Aid flow (current US$) in Iraq?
Give a very brief answer. 1.25e+07. In the year 1981, what is the difference between the Aid flow (current US$) in Guinea-Bissau and Aid flow (current US$) in Sri Lanka?
Your response must be concise. -3.69e+07. In the year 1981, what is the difference between the Aid flow (current US$) in Iraq and Aid flow (current US$) in Madagascar?
Provide a short and direct response. -4.70e+05. In the year 1981, what is the difference between the Aid flow (current US$) in Iraq and Aid flow (current US$) in Sri Lanka?
Ensure brevity in your answer.  -4.94e+07. In the year 1981, what is the difference between the Aid flow (current US$) of Madagascar and Aid flow (current US$) of Sri Lanka?
Keep it short and to the point. -4.89e+07. In the year 1982, what is the difference between the Aid flow (current US$) in Guinea-Bissau and Aid flow (current US$) in Iraq?
Your answer should be very brief. 8.40e+06. In the year 1982, what is the difference between the Aid flow (current US$) of Guinea-Bissau and Aid flow (current US$) of Madagascar?
Your response must be concise. 7.37e+06. In the year 1982, what is the difference between the Aid flow (current US$) of Guinea-Bissau and Aid flow (current US$) of Sri Lanka?
Give a very brief answer. -1.31e+07. In the year 1982, what is the difference between the Aid flow (current US$) of Iraq and Aid flow (current US$) of Madagascar?
Give a very brief answer. -1.03e+06. In the year 1982, what is the difference between the Aid flow (current US$) of Iraq and Aid flow (current US$) of Sri Lanka?
Keep it short and to the point. -2.15e+07. In the year 1982, what is the difference between the Aid flow (current US$) of Madagascar and Aid flow (current US$) of Sri Lanka?
Give a very brief answer. -2.05e+07. In the year 1983, what is the difference between the Aid flow (current US$) of Guinea-Bissau and Aid flow (current US$) of Iraq?
Your answer should be compact. 7.21e+06. In the year 1983, what is the difference between the Aid flow (current US$) of Guinea-Bissau and Aid flow (current US$) of Madagascar?
Give a very brief answer. 6.44e+06. In the year 1983, what is the difference between the Aid flow (current US$) of Guinea-Bissau and Aid flow (current US$) of Sri Lanka?
Keep it short and to the point. -1.82e+07. In the year 1983, what is the difference between the Aid flow (current US$) in Iraq and Aid flow (current US$) in Madagascar?
Provide a short and direct response. -7.70e+05. In the year 1983, what is the difference between the Aid flow (current US$) of Iraq and Aid flow (current US$) of Sri Lanka?
Offer a terse response. -2.54e+07. In the year 1983, what is the difference between the Aid flow (current US$) in Madagascar and Aid flow (current US$) in Sri Lanka?
Offer a very short reply. -2.46e+07. In the year 1984, what is the difference between the Aid flow (current US$) in Guinea-Bissau and Aid flow (current US$) in Iraq?
Your answer should be very brief. 9.53e+06. In the year 1984, what is the difference between the Aid flow (current US$) of Guinea-Bissau and Aid flow (current US$) of Madagascar?
Your answer should be very brief. 9.26e+06. In the year 1984, what is the difference between the Aid flow (current US$) in Guinea-Bissau and Aid flow (current US$) in Sri Lanka?
Ensure brevity in your answer.  -1.11e+07. In the year 1984, what is the difference between the Aid flow (current US$) in Iraq and Aid flow (current US$) in Sri Lanka?
Provide a succinct answer. -2.06e+07. In the year 1984, what is the difference between the Aid flow (current US$) in Madagascar and Aid flow (current US$) in Sri Lanka?
Your answer should be compact. -2.04e+07. In the year 1985, what is the difference between the Aid flow (current US$) in Guinea-Bissau and Aid flow (current US$) in Iraq?
Offer a very short reply. 4.25e+06. In the year 1985, what is the difference between the Aid flow (current US$) in Guinea-Bissau and Aid flow (current US$) in Madagascar?
Make the answer very short. 4.14e+06. In the year 1985, what is the difference between the Aid flow (current US$) in Guinea-Bissau and Aid flow (current US$) in Sri Lanka?
Your response must be concise. -1.01e+07. In the year 1985, what is the difference between the Aid flow (current US$) in Iraq and Aid flow (current US$) in Sri Lanka?
Your answer should be very brief. -1.44e+07. In the year 1985, what is the difference between the Aid flow (current US$) in Madagascar and Aid flow (current US$) in Sri Lanka?
Your answer should be compact. -1.43e+07. In the year 1986, what is the difference between the Aid flow (current US$) of Guinea-Bissau and Aid flow (current US$) of Iraq?
Make the answer very short. 7.45e+06. In the year 1986, what is the difference between the Aid flow (current US$) of Guinea-Bissau and Aid flow (current US$) of Madagascar?
Your answer should be compact. 5.57e+06. In the year 1986, what is the difference between the Aid flow (current US$) in Guinea-Bissau and Aid flow (current US$) in Sri Lanka?
Give a very brief answer. -9.70e+06. In the year 1986, what is the difference between the Aid flow (current US$) in Iraq and Aid flow (current US$) in Madagascar?
Your answer should be very brief. -1.88e+06. In the year 1986, what is the difference between the Aid flow (current US$) of Iraq and Aid flow (current US$) of Sri Lanka?
Make the answer very short. -1.72e+07. In the year 1986, what is the difference between the Aid flow (current US$) in Madagascar and Aid flow (current US$) in Sri Lanka?
Provide a succinct answer. -1.53e+07. In the year 1987, what is the difference between the Aid flow (current US$) of Guinea-Bissau and Aid flow (current US$) of Iraq?
Offer a very short reply. 9.53e+06. In the year 1987, what is the difference between the Aid flow (current US$) in Guinea-Bissau and Aid flow (current US$) in Madagascar?
Provide a succinct answer. 9.08e+06. In the year 1987, what is the difference between the Aid flow (current US$) of Guinea-Bissau and Aid flow (current US$) of Sri Lanka?
Ensure brevity in your answer.  -1.39e+07. In the year 1987, what is the difference between the Aid flow (current US$) of Iraq and Aid flow (current US$) of Madagascar?
Your response must be concise. -4.50e+05. In the year 1987, what is the difference between the Aid flow (current US$) in Iraq and Aid flow (current US$) in Sri Lanka?
Provide a short and direct response. -2.34e+07. In the year 1987, what is the difference between the Aid flow (current US$) in Madagascar and Aid flow (current US$) in Sri Lanka?
Make the answer very short. -2.30e+07. What is the ratio of the Aid flow (current US$) of Guinea-Bissau in 1980 to that in 1981?
Offer a very short reply. 1.12. What is the ratio of the Aid flow (current US$) in Iraq in 1980 to that in 1981?
Give a very brief answer. 0.67. What is the ratio of the Aid flow (current US$) in Madagascar in 1980 to that in 1981?
Your response must be concise. 1.41. What is the ratio of the Aid flow (current US$) in Sri Lanka in 1980 to that in 1981?
Offer a very short reply. 0.46. What is the ratio of the Aid flow (current US$) of Guinea-Bissau in 1980 to that in 1982?
Your answer should be very brief. 1.67. What is the ratio of the Aid flow (current US$) in Madagascar in 1980 to that in 1982?
Offer a terse response. 0.75. What is the ratio of the Aid flow (current US$) of Sri Lanka in 1980 to that in 1982?
Your answer should be very brief. 1.05. What is the ratio of the Aid flow (current US$) of Guinea-Bissau in 1980 to that in 1983?
Ensure brevity in your answer.  1.95. What is the ratio of the Aid flow (current US$) of Iraq in 1980 to that in 1983?
Provide a succinct answer. 6. What is the ratio of the Aid flow (current US$) in Madagascar in 1980 to that in 1983?
Make the answer very short. 1.01. What is the ratio of the Aid flow (current US$) in Sri Lanka in 1980 to that in 1983?
Provide a succinct answer. 0.89. What is the ratio of the Aid flow (current US$) of Guinea-Bissau in 1980 to that in 1984?
Your response must be concise. 1.48. What is the ratio of the Aid flow (current US$) in Madagascar in 1980 to that in 1984?
Your answer should be compact. 2.72. What is the ratio of the Aid flow (current US$) of Sri Lanka in 1980 to that in 1984?
Provide a succinct answer. 1.1. What is the ratio of the Aid flow (current US$) in Guinea-Bissau in 1980 to that in 1985?
Provide a short and direct response. 3.27. What is the ratio of the Aid flow (current US$) of Iraq in 1980 to that in 1985?
Your answer should be compact. 1. What is the ratio of the Aid flow (current US$) in Madagascar in 1980 to that in 1985?
Offer a terse response. 4.65. What is the ratio of the Aid flow (current US$) in Sri Lanka in 1980 to that in 1985?
Provide a short and direct response. 1.57. What is the ratio of the Aid flow (current US$) of Guinea-Bissau in 1980 to that in 1986?
Ensure brevity in your answer.  1.87. What is the ratio of the Aid flow (current US$) in Iraq in 1980 to that in 1986?
Make the answer very short. 0.86. What is the ratio of the Aid flow (current US$) in Madagascar in 1980 to that in 1986?
Offer a terse response. 0.41. What is the ratio of the Aid flow (current US$) of Sri Lanka in 1980 to that in 1986?
Your answer should be compact. 1.32. What is the ratio of the Aid flow (current US$) in Guinea-Bissau in 1980 to that in 1987?
Your answer should be compact. 1.47. What is the ratio of the Aid flow (current US$) of Madagascar in 1980 to that in 1987?
Ensure brevity in your answer.  1.49. What is the ratio of the Aid flow (current US$) of Sri Lanka in 1980 to that in 1987?
Keep it short and to the point. 0.97. What is the ratio of the Aid flow (current US$) of Guinea-Bissau in 1981 to that in 1982?
Provide a short and direct response. 1.49. What is the ratio of the Aid flow (current US$) of Madagascar in 1981 to that in 1982?
Keep it short and to the point. 0.53. What is the ratio of the Aid flow (current US$) in Sri Lanka in 1981 to that in 1982?
Provide a succinct answer. 2.3. What is the ratio of the Aid flow (current US$) of Guinea-Bissau in 1981 to that in 1983?
Your answer should be compact. 1.74. What is the ratio of the Aid flow (current US$) in Iraq in 1981 to that in 1983?
Keep it short and to the point. 9. What is the ratio of the Aid flow (current US$) of Madagascar in 1981 to that in 1983?
Keep it short and to the point. 0.72. What is the ratio of the Aid flow (current US$) in Sri Lanka in 1981 to that in 1983?
Your answer should be very brief. 1.95. What is the ratio of the Aid flow (current US$) of Guinea-Bissau in 1981 to that in 1984?
Provide a short and direct response. 1.32. What is the ratio of the Aid flow (current US$) in Iraq in 1981 to that in 1984?
Give a very brief answer. 4.5. What is the ratio of the Aid flow (current US$) of Madagascar in 1981 to that in 1984?
Your answer should be compact. 1.93. What is the ratio of the Aid flow (current US$) in Sri Lanka in 1981 to that in 1984?
Make the answer very short. 2.4. What is the ratio of the Aid flow (current US$) in Guinea-Bissau in 1981 to that in 1985?
Make the answer very short. 2.91. What is the ratio of the Aid flow (current US$) of Iraq in 1981 to that in 1985?
Offer a terse response. 1.5. What is the ratio of the Aid flow (current US$) of Madagascar in 1981 to that in 1985?
Your answer should be very brief. 3.29. What is the ratio of the Aid flow (current US$) in Sri Lanka in 1981 to that in 1985?
Make the answer very short. 3.42. What is the ratio of the Aid flow (current US$) in Guinea-Bissau in 1981 to that in 1986?
Provide a succinct answer. 1.67. What is the ratio of the Aid flow (current US$) of Madagascar in 1981 to that in 1986?
Make the answer very short. 0.29. What is the ratio of the Aid flow (current US$) in Sri Lanka in 1981 to that in 1986?
Keep it short and to the point. 2.87. What is the ratio of the Aid flow (current US$) of Guinea-Bissau in 1981 to that in 1987?
Give a very brief answer. 1.31. What is the ratio of the Aid flow (current US$) in Iraq in 1981 to that in 1987?
Give a very brief answer. 1.12. What is the ratio of the Aid flow (current US$) of Madagascar in 1981 to that in 1987?
Your answer should be very brief. 1.06. What is the ratio of the Aid flow (current US$) in Sri Lanka in 1981 to that in 1987?
Your response must be concise. 2.1. What is the ratio of the Aid flow (current US$) in Guinea-Bissau in 1982 to that in 1983?
Give a very brief answer. 1.17. What is the ratio of the Aid flow (current US$) of Madagascar in 1982 to that in 1983?
Give a very brief answer. 1.36. What is the ratio of the Aid flow (current US$) in Sri Lanka in 1982 to that in 1983?
Give a very brief answer. 0.85. What is the ratio of the Aid flow (current US$) in Guinea-Bissau in 1982 to that in 1984?
Ensure brevity in your answer.  0.88. What is the ratio of the Aid flow (current US$) of Iraq in 1982 to that in 1984?
Your answer should be very brief. 1.5. What is the ratio of the Aid flow (current US$) in Madagascar in 1982 to that in 1984?
Ensure brevity in your answer.  3.66. What is the ratio of the Aid flow (current US$) of Sri Lanka in 1982 to that in 1984?
Give a very brief answer. 1.04. What is the ratio of the Aid flow (current US$) in Guinea-Bissau in 1982 to that in 1985?
Provide a succinct answer. 1.96. What is the ratio of the Aid flow (current US$) of Madagascar in 1982 to that in 1985?
Ensure brevity in your answer.  6.24. What is the ratio of the Aid flow (current US$) of Sri Lanka in 1982 to that in 1985?
Give a very brief answer. 1.49. What is the ratio of the Aid flow (current US$) in Guinea-Bissau in 1982 to that in 1986?
Your answer should be very brief. 1.12. What is the ratio of the Aid flow (current US$) in Iraq in 1982 to that in 1986?
Provide a succinct answer. 0.43. What is the ratio of the Aid flow (current US$) in Madagascar in 1982 to that in 1986?
Provide a succinct answer. 0.54. What is the ratio of the Aid flow (current US$) in Sri Lanka in 1982 to that in 1986?
Give a very brief answer. 1.25. What is the ratio of the Aid flow (current US$) in Guinea-Bissau in 1982 to that in 1987?
Make the answer very short. 0.88. What is the ratio of the Aid flow (current US$) in Iraq in 1982 to that in 1987?
Your answer should be very brief. 0.38. What is the ratio of the Aid flow (current US$) of Sri Lanka in 1982 to that in 1987?
Offer a terse response. 0.92. What is the ratio of the Aid flow (current US$) of Guinea-Bissau in 1983 to that in 1984?
Make the answer very short. 0.76. What is the ratio of the Aid flow (current US$) of Madagascar in 1983 to that in 1984?
Your answer should be very brief. 2.69. What is the ratio of the Aid flow (current US$) of Sri Lanka in 1983 to that in 1984?
Your answer should be compact. 1.23. What is the ratio of the Aid flow (current US$) of Guinea-Bissau in 1983 to that in 1985?
Give a very brief answer. 1.68. What is the ratio of the Aid flow (current US$) in Iraq in 1983 to that in 1985?
Offer a very short reply. 0.17. What is the ratio of the Aid flow (current US$) in Madagascar in 1983 to that in 1985?
Ensure brevity in your answer.  4.59. What is the ratio of the Aid flow (current US$) in Sri Lanka in 1983 to that in 1985?
Keep it short and to the point. 1.76. What is the ratio of the Aid flow (current US$) of Guinea-Bissau in 1983 to that in 1986?
Make the answer very short. 0.96. What is the ratio of the Aid flow (current US$) in Iraq in 1983 to that in 1986?
Give a very brief answer. 0.14. What is the ratio of the Aid flow (current US$) in Madagascar in 1983 to that in 1986?
Offer a terse response. 0.4. What is the ratio of the Aid flow (current US$) of Sri Lanka in 1983 to that in 1986?
Provide a short and direct response. 1.48. What is the ratio of the Aid flow (current US$) of Guinea-Bissau in 1983 to that in 1987?
Provide a short and direct response. 0.75. What is the ratio of the Aid flow (current US$) of Madagascar in 1983 to that in 1987?
Give a very brief answer. 1.47. What is the ratio of the Aid flow (current US$) of Sri Lanka in 1983 to that in 1987?
Your answer should be compact. 1.08. What is the ratio of the Aid flow (current US$) in Guinea-Bissau in 1984 to that in 1985?
Offer a very short reply. 2.22. What is the ratio of the Aid flow (current US$) in Iraq in 1984 to that in 1985?
Provide a succinct answer. 0.33. What is the ratio of the Aid flow (current US$) of Madagascar in 1984 to that in 1985?
Provide a short and direct response. 1.71. What is the ratio of the Aid flow (current US$) in Sri Lanka in 1984 to that in 1985?
Provide a short and direct response. 1.43. What is the ratio of the Aid flow (current US$) of Guinea-Bissau in 1984 to that in 1986?
Make the answer very short. 1.27. What is the ratio of the Aid flow (current US$) of Iraq in 1984 to that in 1986?
Provide a short and direct response. 0.29. What is the ratio of the Aid flow (current US$) of Madagascar in 1984 to that in 1986?
Ensure brevity in your answer.  0.15. What is the ratio of the Aid flow (current US$) of Sri Lanka in 1984 to that in 1986?
Provide a succinct answer. 1.2. What is the ratio of the Aid flow (current US$) in Madagascar in 1984 to that in 1987?
Offer a terse response. 0.55. What is the ratio of the Aid flow (current US$) in Sri Lanka in 1984 to that in 1987?
Keep it short and to the point. 0.88. What is the ratio of the Aid flow (current US$) of Guinea-Bissau in 1985 to that in 1986?
Offer a very short reply. 0.57. What is the ratio of the Aid flow (current US$) of Madagascar in 1985 to that in 1986?
Ensure brevity in your answer.  0.09. What is the ratio of the Aid flow (current US$) in Sri Lanka in 1985 to that in 1986?
Ensure brevity in your answer.  0.84. What is the ratio of the Aid flow (current US$) of Guinea-Bissau in 1985 to that in 1987?
Keep it short and to the point. 0.45. What is the ratio of the Aid flow (current US$) in Iraq in 1985 to that in 1987?
Provide a short and direct response. 0.75. What is the ratio of the Aid flow (current US$) in Madagascar in 1985 to that in 1987?
Your answer should be compact. 0.32. What is the ratio of the Aid flow (current US$) of Sri Lanka in 1985 to that in 1987?
Offer a very short reply. 0.61. What is the ratio of the Aid flow (current US$) of Guinea-Bissau in 1986 to that in 1987?
Your answer should be compact. 0.78. What is the ratio of the Aid flow (current US$) in Iraq in 1986 to that in 1987?
Your answer should be compact. 0.88. What is the ratio of the Aid flow (current US$) in Madagascar in 1986 to that in 1987?
Offer a terse response. 3.68. What is the ratio of the Aid flow (current US$) of Sri Lanka in 1986 to that in 1987?
Offer a terse response. 0.73. What is the difference between the highest and the second highest Aid flow (current US$) of Guinea-Bissau?
Offer a very short reply. 1.53e+06. What is the difference between the highest and the second highest Aid flow (current US$) in Madagascar?
Offer a terse response. 8.90e+05. What is the difference between the highest and the second highest Aid flow (current US$) in Sri Lanka?
Your answer should be compact. 2.41e+07. What is the difference between the highest and the lowest Aid flow (current US$) in Guinea-Bissau?
Your answer should be very brief. 9.78e+06. What is the difference between the highest and the lowest Aid flow (current US$) of Madagascar?
Your response must be concise. 1.78e+06. What is the difference between the highest and the lowest Aid flow (current US$) in Sri Lanka?
Make the answer very short. 3.50e+07. 